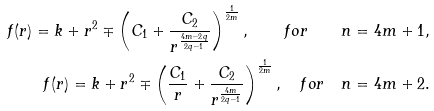Convert formula to latex. <formula><loc_0><loc_0><loc_500><loc_500>f ( r ) = k + r ^ { 2 } \mp \left ( C _ { 1 } + \frac { C _ { 2 } } { r ^ { \frac { 4 m - 2 q } { 2 q - 1 } } } \right ) ^ { \frac { 1 } { 2 m } } , \quad f o r \quad n = 4 m + 1 , \\ f ( r ) = k + r ^ { 2 } \mp \left ( \frac { C _ { 1 } } { r } + \frac { C _ { 2 } } { r ^ { \frac { 4 m } { 2 q - 1 } } } \right ) ^ { \frac { 1 } { 2 m } } , \quad f o r \quad n = 4 m + 2 .</formula> 